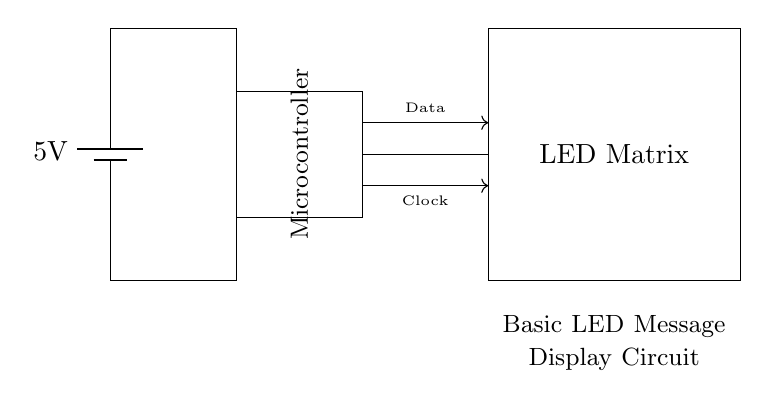What is the voltage of this circuit? The voltage is labeled as 5V, which indicates the power supply voltage necessary for the circuit to function. This comes from the battery in the circuit diagram.
Answer: 5 volts What component is responsible for processing data in the circuit? The component that processes data in the circuit is the microcontroller. It is depicted as a rectangle and labeled accordingly.
Answer: Microcontroller How many main components are present in the circuit? The circuit has three main components: the battery, the microcontroller, and the LED matrix. Each component plays a critical role in the overall function of the circuit.
Answer: Three What type of display is used in this circuit? The circuit employs an LED matrix for visual display, as indicated by the labeled rectangle in the diagram.
Answer: LED matrix What type of signals are being transferred to the LED matrix? The signals transferred to the LED matrix are labeled as "Data" and "Clock," indicating the types of information sent from the microcontroller to control the LED display.
Answer: Data and Clock How does the microcontroller communicate with the LED matrix? The microcontroller communicates with the LED matrix using two lines: one for data transmission and one for clock signals, as shown by the arrows pointing from the microcontroller to the LED matrix.
Answer: Data and Clock signals What is the purpose of the battery in this circuit? The battery serves as the power source, providing the necessary voltage (5V) to operate the circuit, enabling all components to function correctly.
Answer: Power source 